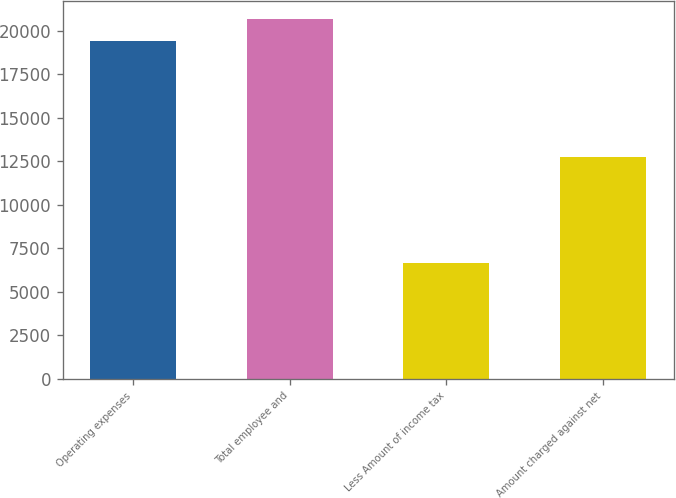Convert chart to OTSL. <chart><loc_0><loc_0><loc_500><loc_500><bar_chart><fcel>Operating expenses<fcel>Total employee and<fcel>Less Amount of income tax<fcel>Amount charged against net<nl><fcel>19423<fcel>20700.8<fcel>6646<fcel>12778<nl></chart> 